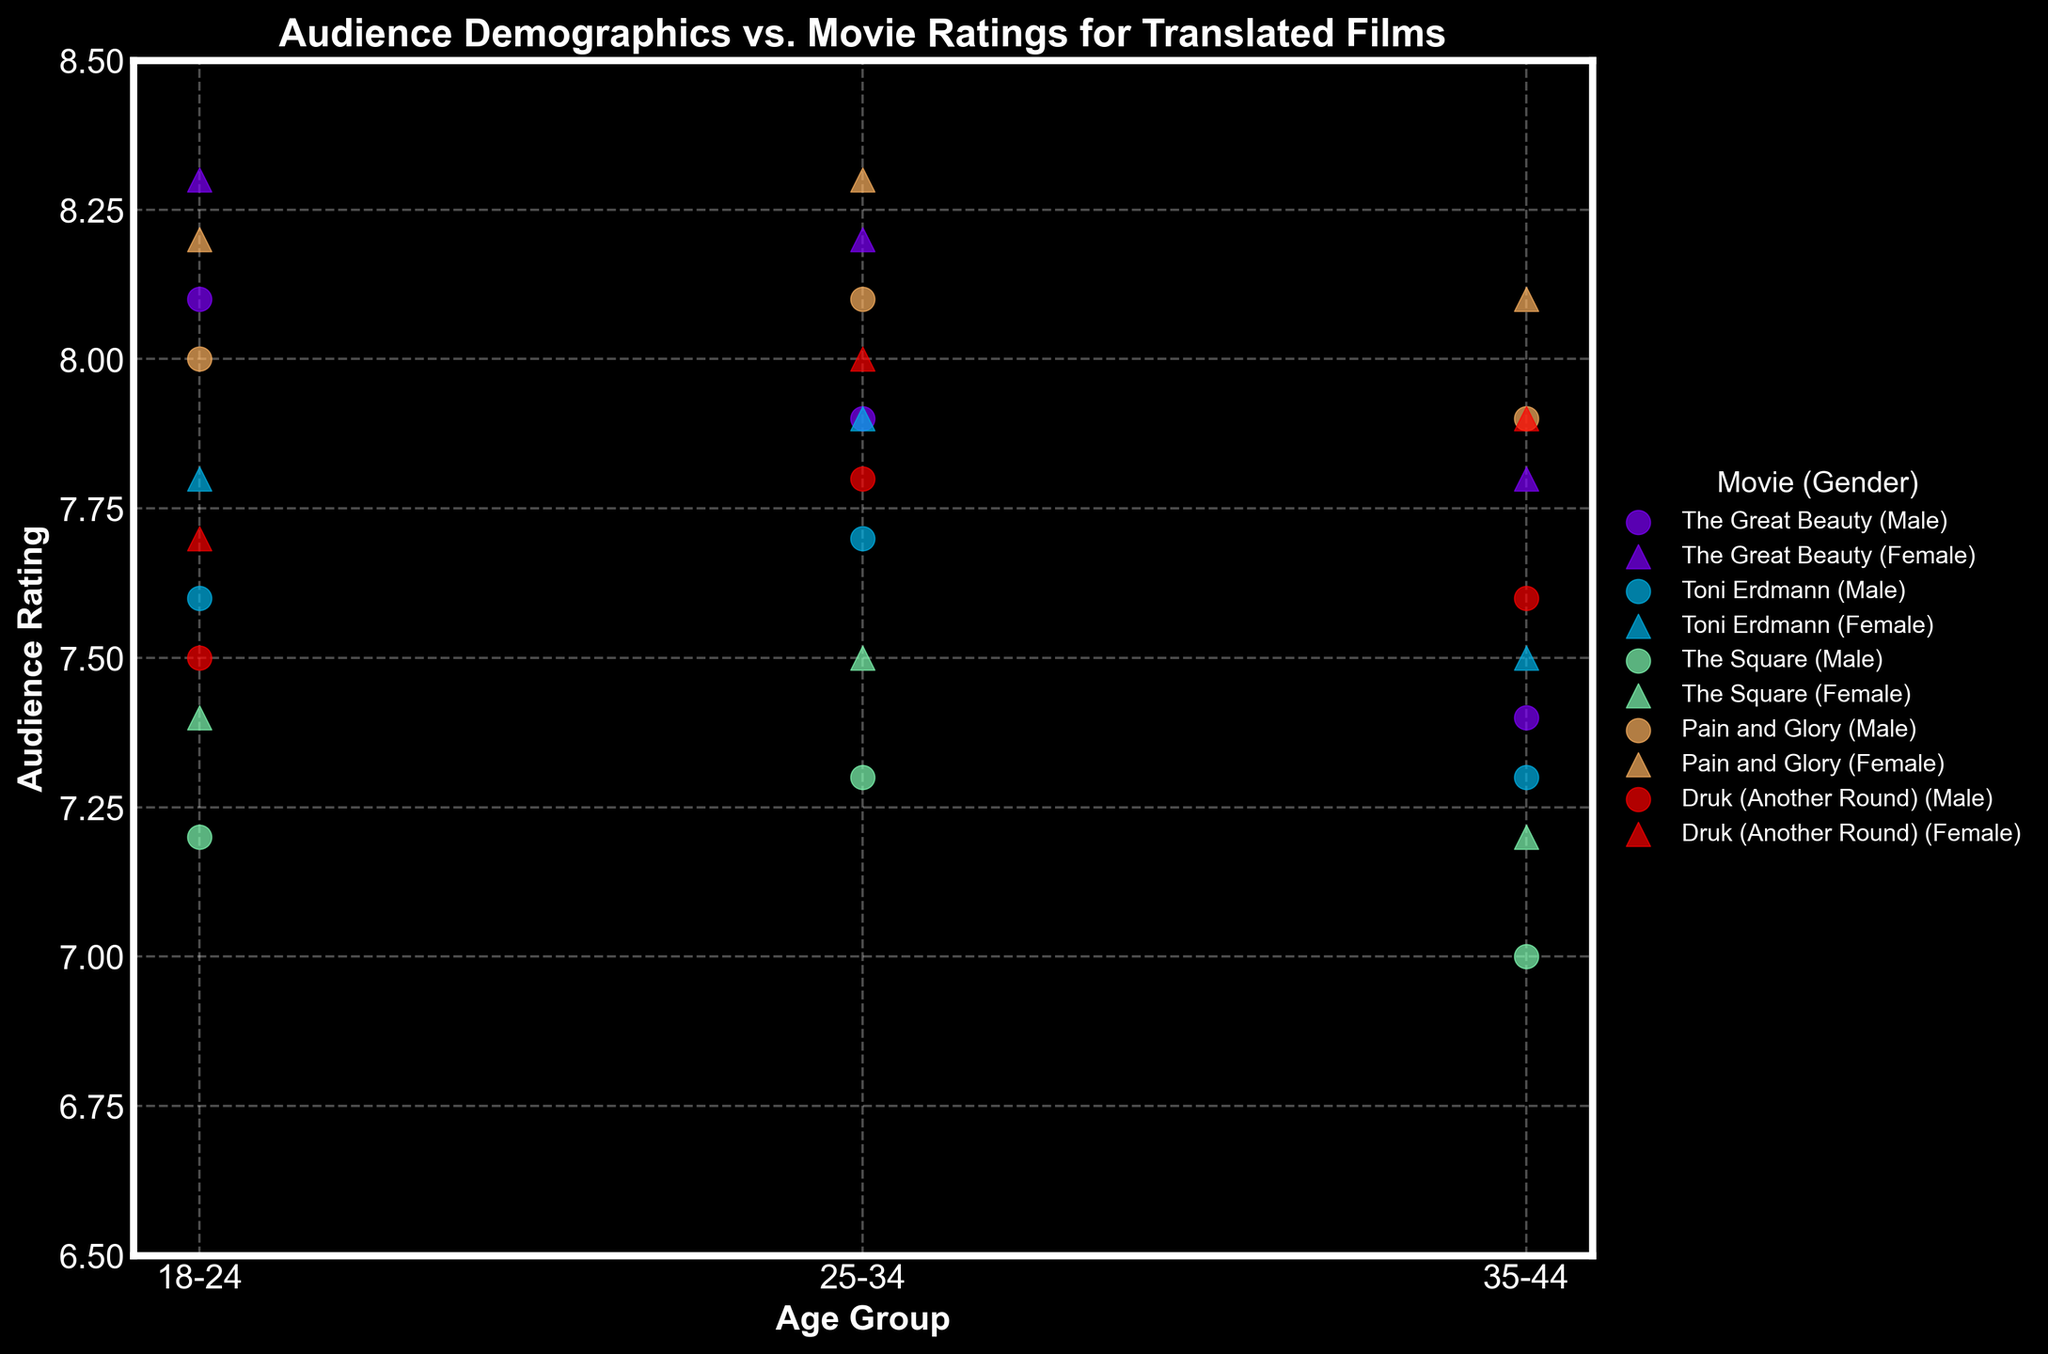What is the title of the plot? The title is displayed at the top of the plot. It reads "Audience Demographics vs. Movie Ratings for Translated Films".
Answer: Audience Demographics vs. Movie Ratings for Translated Films Which age group has the highest rating for "Pain and Glory"? To find this, locate the data points for "Pain and Glory" in different age groups. Compare their ratings: Age 18-24 is 8.0 (Male) and 8.2 (Female); Age 25-34 is 8.1 (Male) and 8.3 (Female); Age 35-44 is 7.9 (Male) and 8.1 (Female). The highest rating is for the Age 25-34 group (Female) with a rating of 8.3.
Answer: Age 25-34 How do male and female ratings for "The Great Beauty" differ in the 18-24 age group? Look at the markers for males and females in the 18-24 age group for "The Great Beauty". Male ratings are 8.1 and female ratings are 8.3.
Answer: Female ratings are 0.2 higher What is the average rating for "Toni Erdmann"? Sum up all the ratings for "Toni Erdmann", which are 7.6, 7.8, 7.7, 7.9, 7.3, and 7.5. Their average is \( \frac{7.6 + 7.8 + 7.7 + 7.9 + 7.3 + 7.5}{6} = 7.63 \).
Answer: 7.63 Which translated film received the highest audience rating overall? Compare the highest ratings for each film: "The Great Beauty" (8.3), "Toni Erdmann" (7.9), "The Square" (7.5), "Pain and Glory" (8.3), and "Druk (Another Round)" (8.0). The highest ratings are 8.3 for both "The Great Beauty" and "Pain and Glory".
Answer: The Great Beauty and Pain and Glory In which movie do female audiences consistently rate higher than male audiences? Compare the ratings for males and females for each age group. For "Pain and Glory", female ratings are 8.2, 8.3, and 8.1, which are higher than male ratings of 8.0, 8.1, and 7.9 respectively. This trend is not consistent for other movies.
Answer: Pain and Glory What is the rating range for "The Square"? Identify the highest and lowest ratings for "The Square". The ratings are 7.2, 7.4, 7.3, 7.5, 7.0, and 7.2. The range is 7.5 (highest) - 7.0 (lowest) = 0.5.
Answer: 0.5 Do older audiences (35-44) tend to rate the movies lower than younger audiences (18-24)? Compare the ratings across all movies for these two age groups: Older audiences' ratings for "The Great Beauty", "Toni Erdmann", "The Square", "Pain and Glory", and "Druk (Another Round)" are 7.4, 7.3, 7.0, 7.9, 7.6 (Male) and 7.8, 7.5, 7.2, 8.1, 7.9 (Female), which are mostly lower than those for younger audiences. Yes, this trend is seen.
Answer: Yes Which movie shows the smallest variation in ratings across different age groups? Calculate the range (max - min) of ratings for each movie: "The Great Beauty" (0.9), "Toni Erdmann" (0.6), "The Square" (0.5), "Pain and Glory" (0.4), "Druk (Another Round)" (0.4). The smallest variation is for "Pain and Glory" and "Druk (Another Round)".
Answer: Pain and Glory and Druk (Another Round) Which translated language film received the highest rating from the 25-34 female audience? Compare the ratings from 25-34 female for each film: "The Great Beauty" (8.2), "Toni Erdmann" (7.9), "The Square" (7.5), "Pain and Glory" (8.3), "Druk (Another Round)" (8.0). The highest rating is 8.3 for "Pain and Glory".
Answer: Pain and Glory 